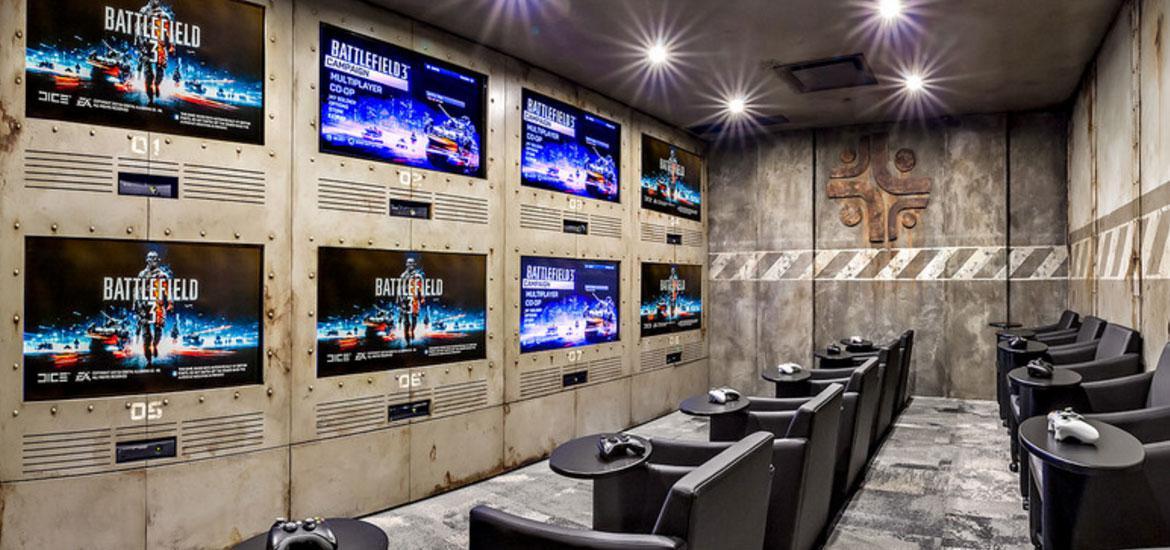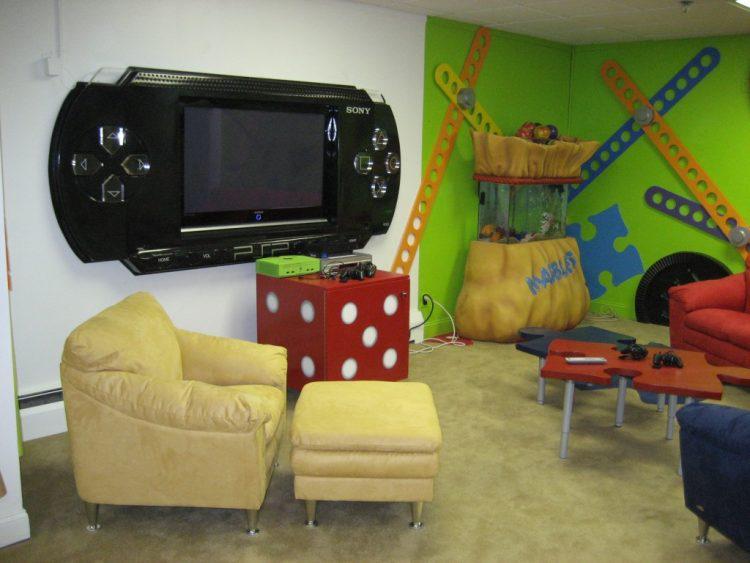The first image is the image on the left, the second image is the image on the right. For the images shown, is this caption "Each image shows one wide screen on a wall, with seating in front of it, and one image shows a screen surrounded by a blue glow." true? Answer yes or no. No. 